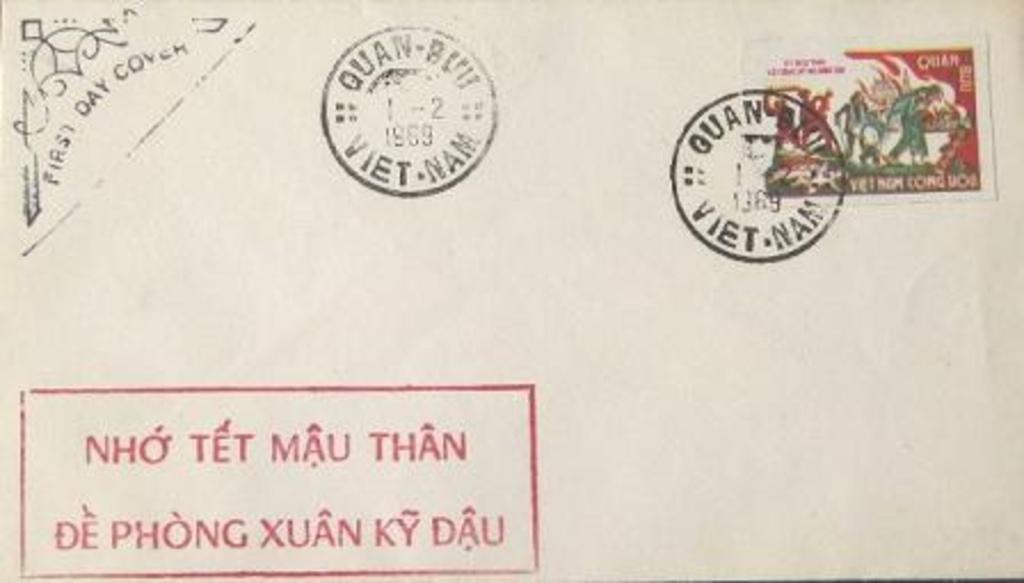What country do the two identical stamps come from?
Your answer should be very brief. Vietnam. What does the top left stamp say?
Give a very brief answer. First day cover. 